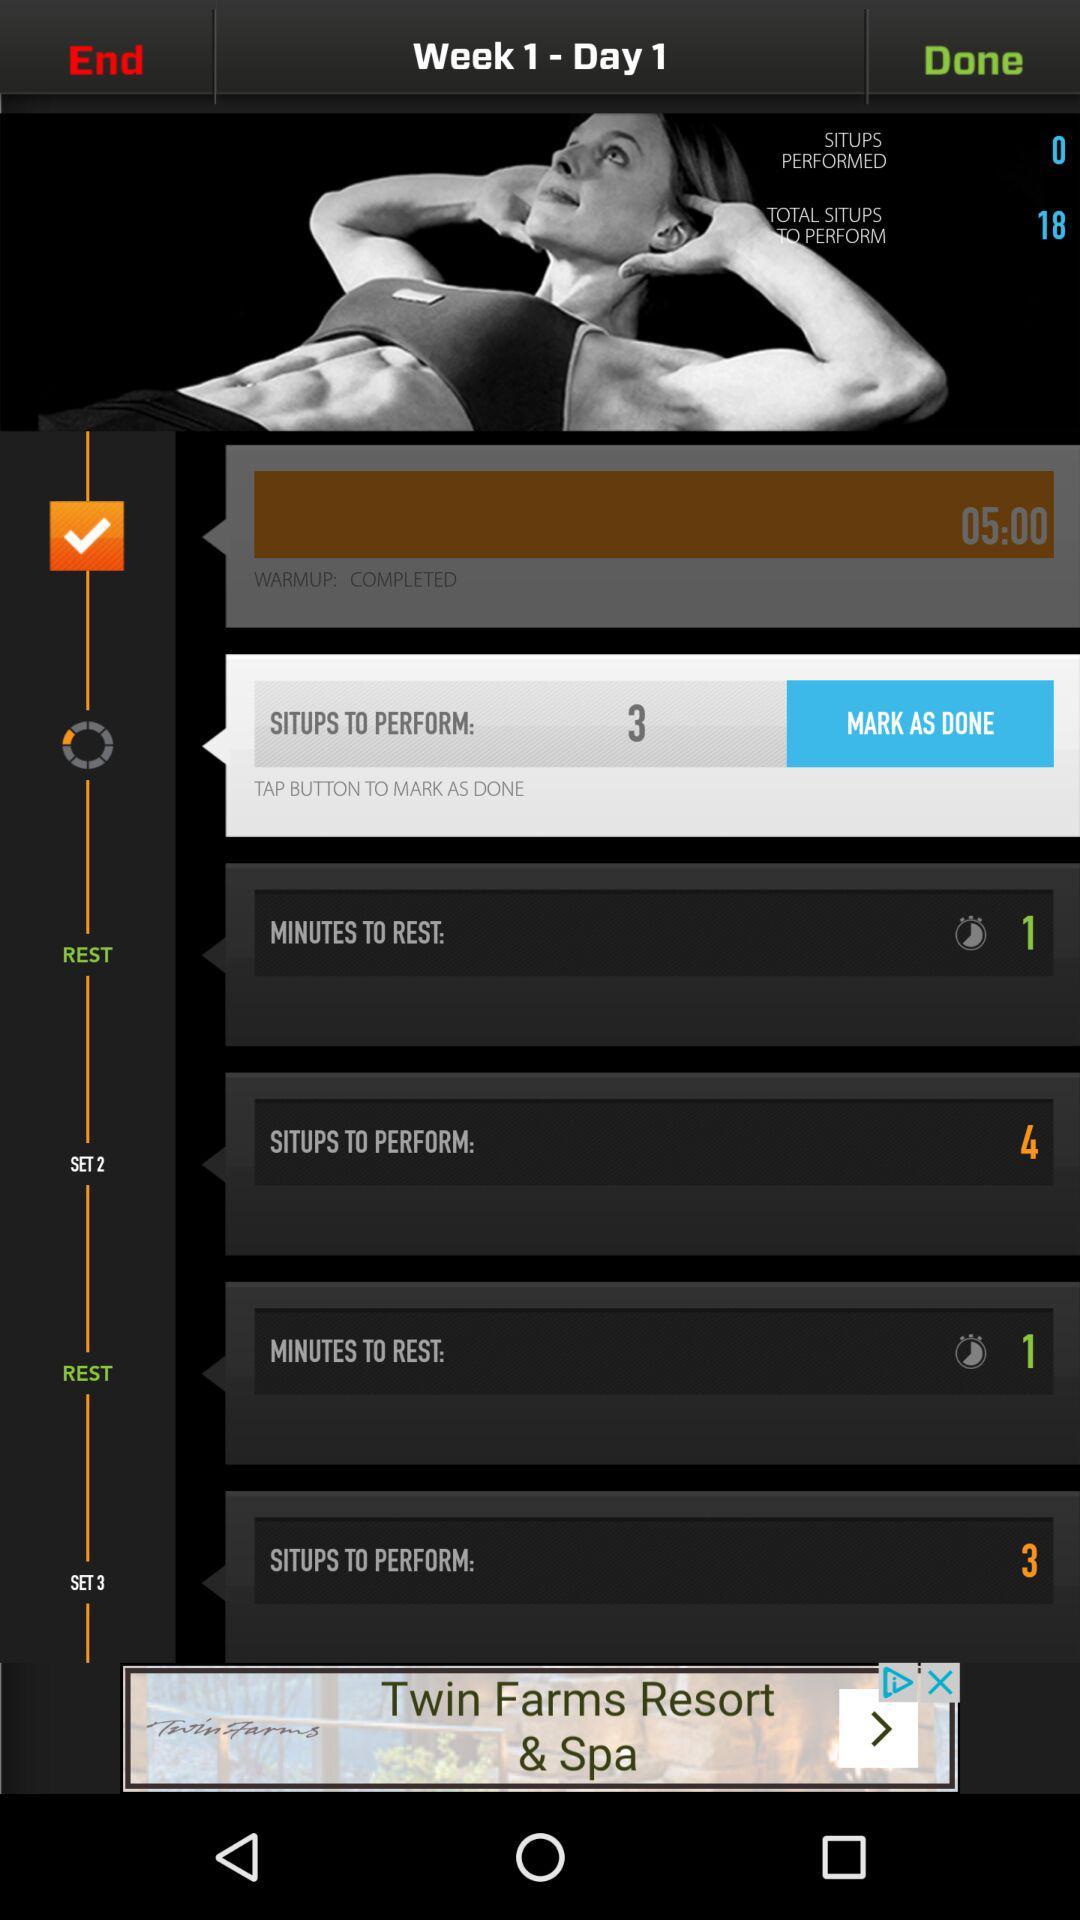What is the status of "WARMUP"? The status is "COMPLETED". 